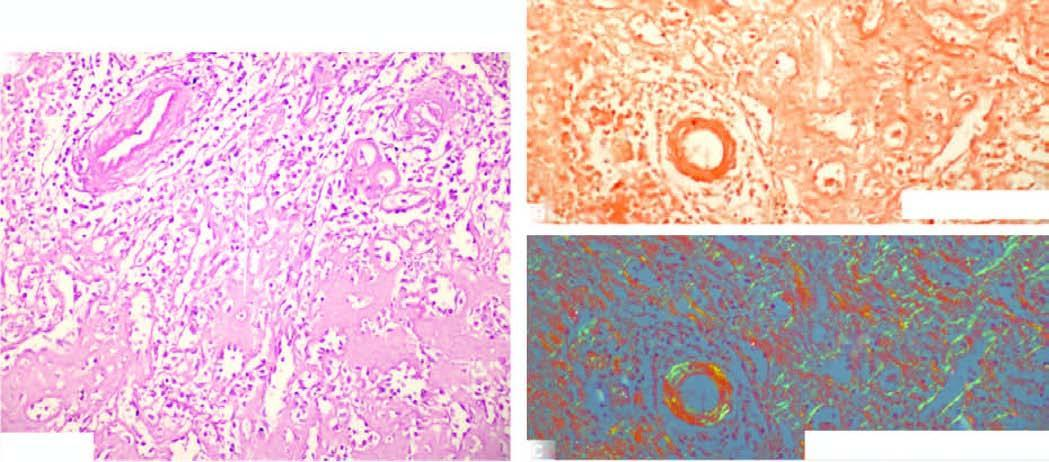where is the pink acellular amyloid material seen?
Answer the question using a single word or phrase. In the red pulp causing atrophy of while pulp 